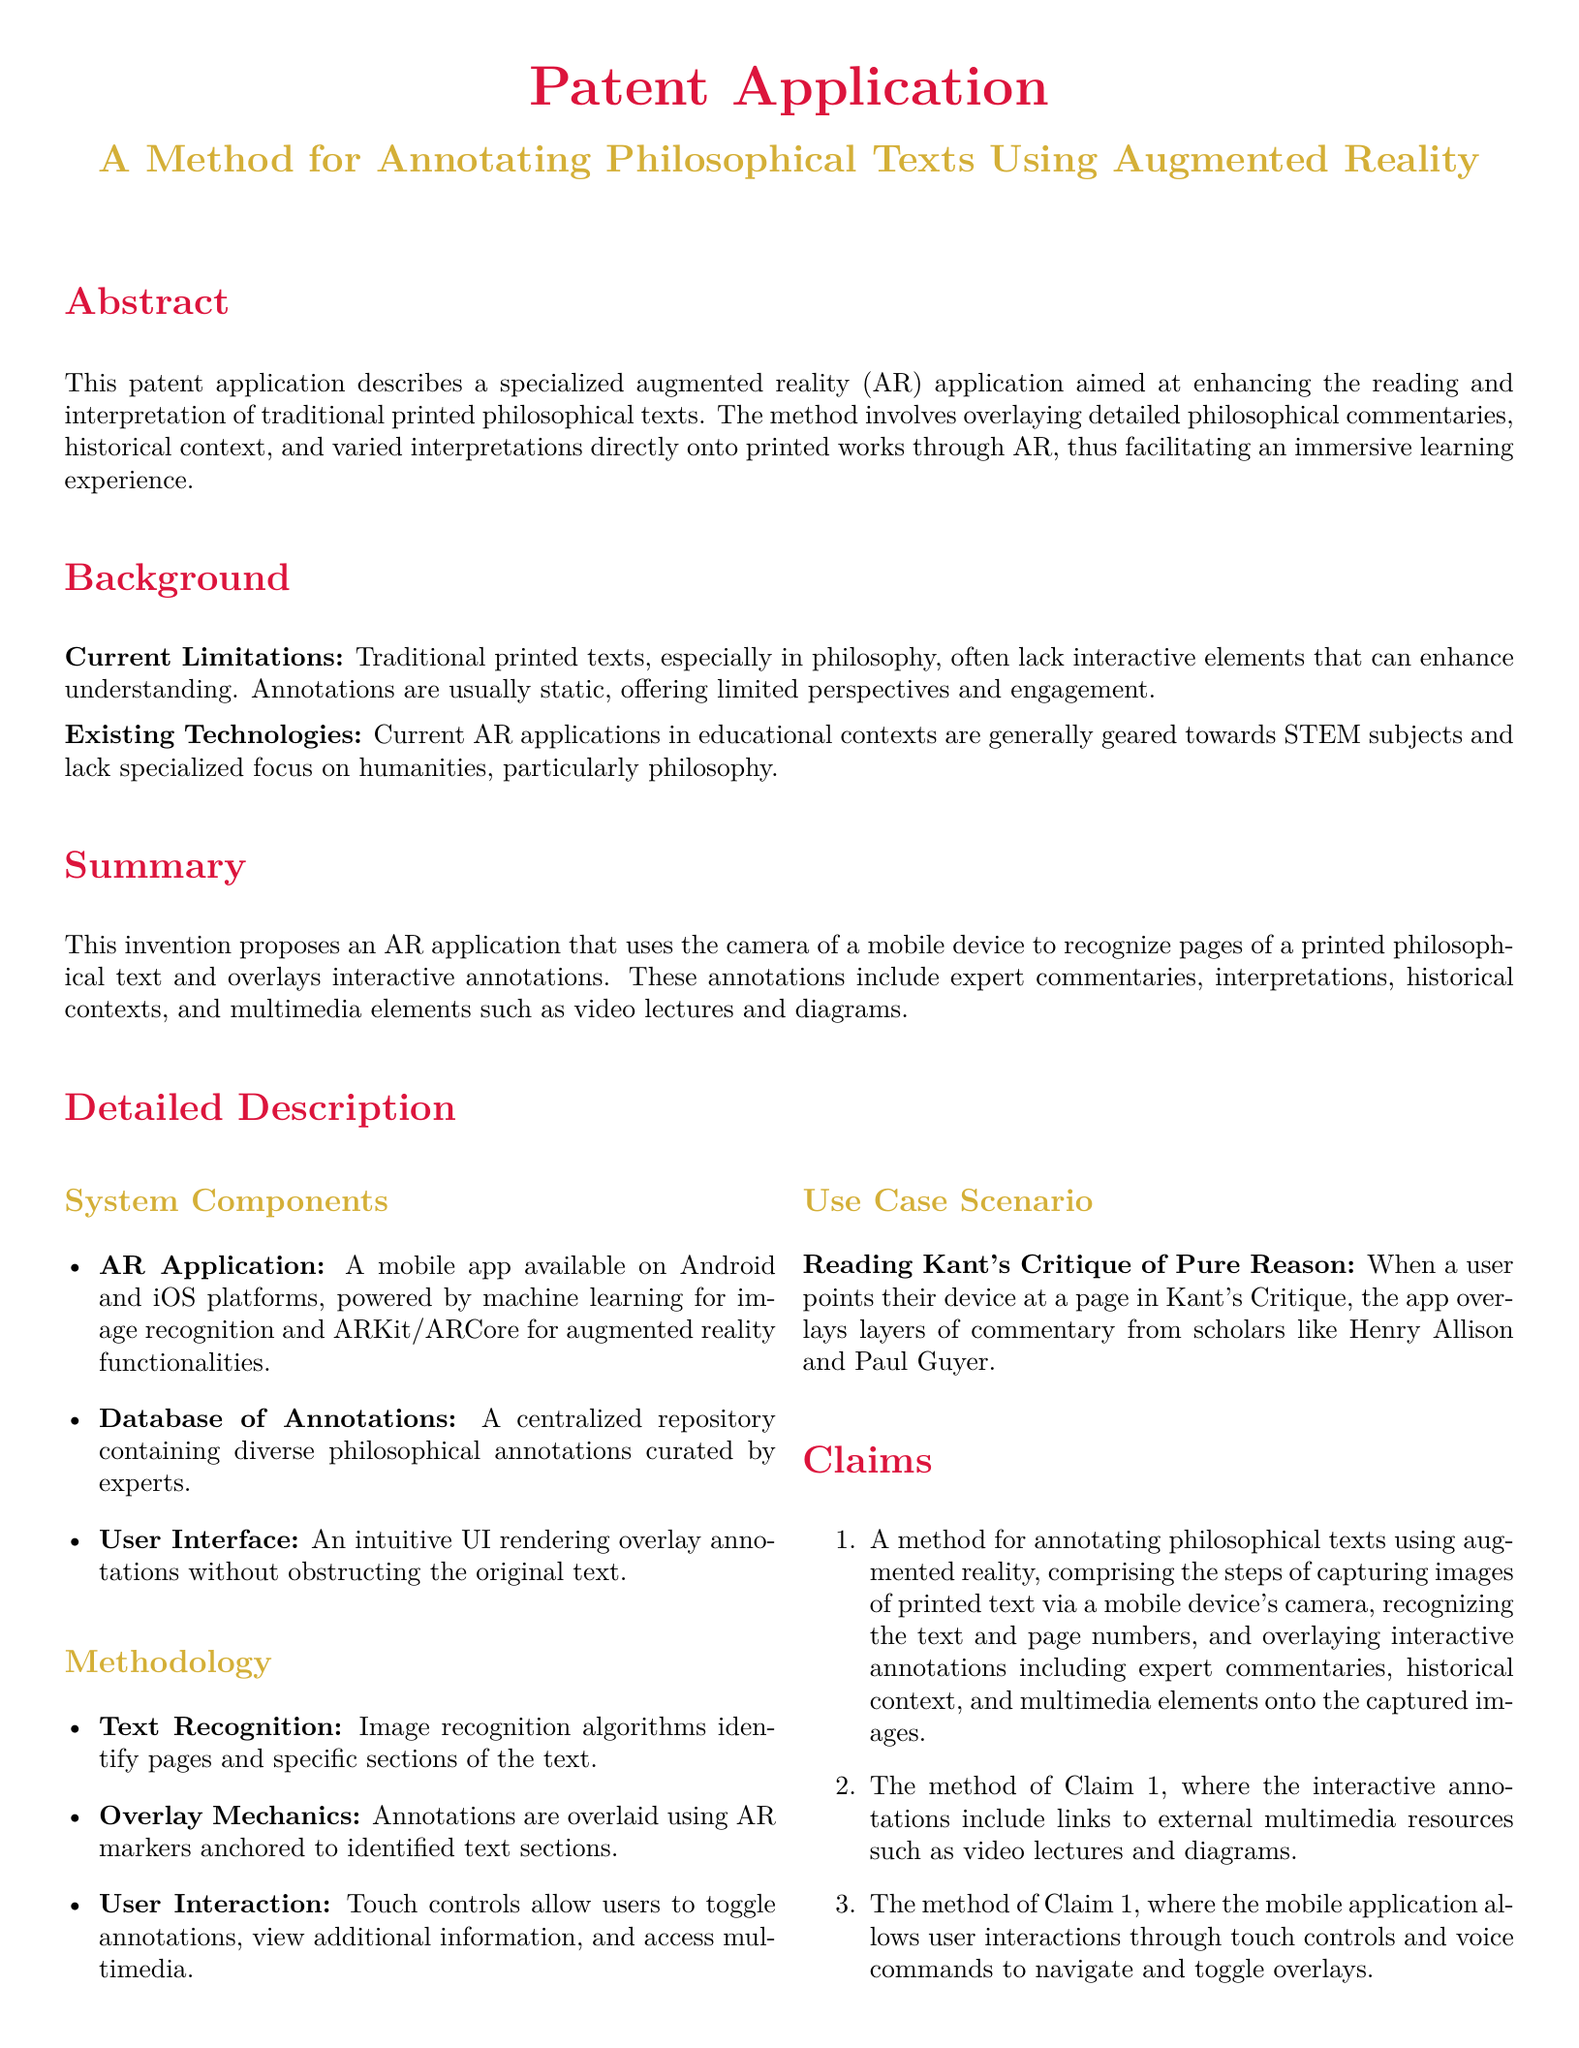What is the title of the patent application? The title is stated at the beginning of the document, under the section detailing the patent application.
Answer: A Method for Annotating Philosophical Texts Using Augmented Reality What technology does the AR application utilize for its functionalities? The document mentions ARKit and ARCore as technologies used for augmented reality functionalities in the application.
Answer: ARKit/ARCore Which philosophical text is used in the use case scenario? The use case scenario specifically names a work by Immanuel Kant that the application is applied to.
Answer: Kant's Critique of Pure Reason How many claims are listed in the patent application? The section detailing claims explicitly states the number of claims presented in the document.
Answer: Three What is one component of the system described in the detailed description? The detailed description lists specific components such as the mobile app, a database of annotations, and user interface.
Answer: AR Application What type of annotations does the method overlay? The document defines the types of annotations that the app overlays, including expert commentaries and historical context.
Answer: Interactive annotations How does the user interact with the annotations? The document describes the methods through which users can engage with the annotations, including touch controls and voice commands.
Answer: Touch controls and voice commands What is the primary purpose of the specialized AR application? The purpose is outlined in the abstract and introduces the main intention behind the development of the application.
Answer: Enhancing reading and interpretation of philosophical texts 